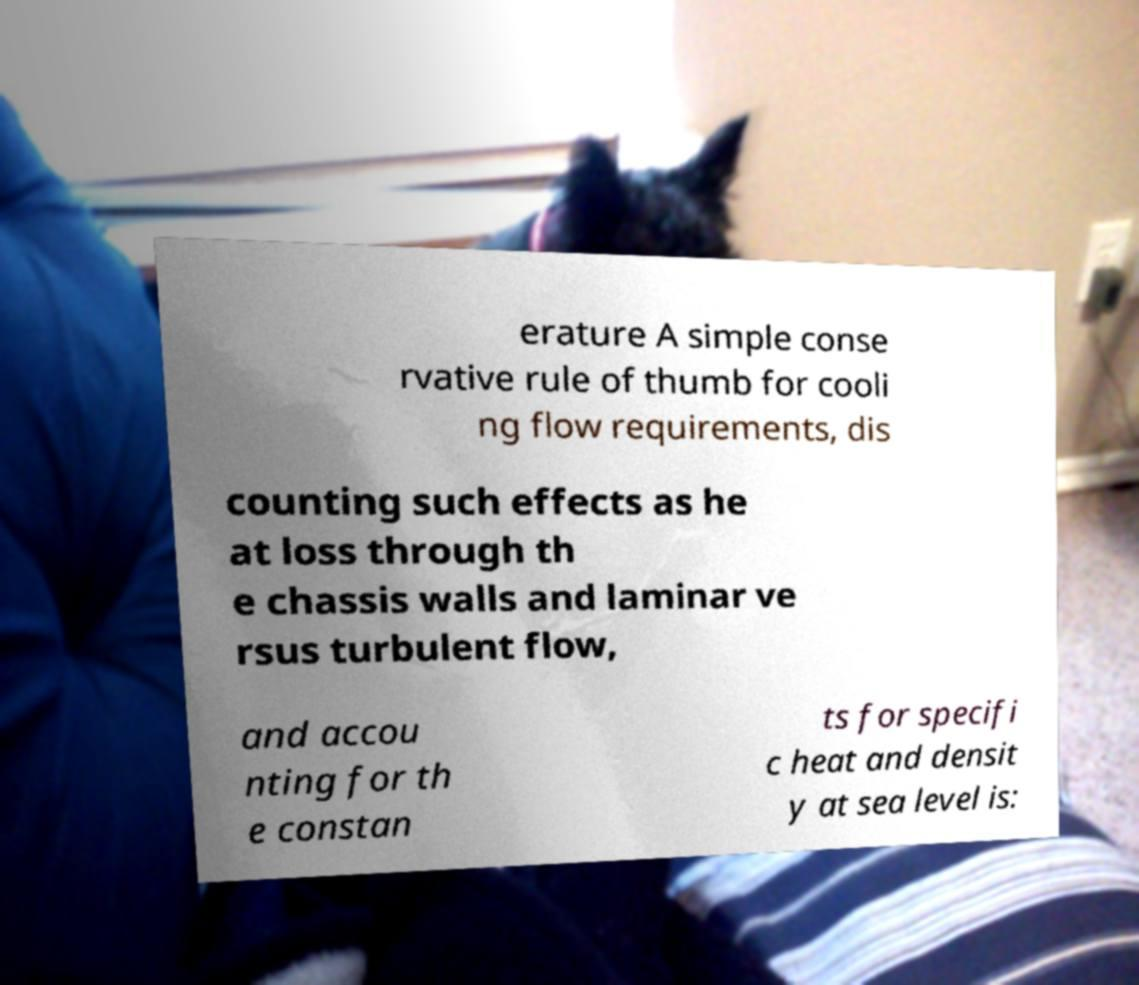Please read and relay the text visible in this image. What does it say? erature A simple conse rvative rule of thumb for cooli ng flow requirements, dis counting such effects as he at loss through th e chassis walls and laminar ve rsus turbulent flow, and accou nting for th e constan ts for specifi c heat and densit y at sea level is: 